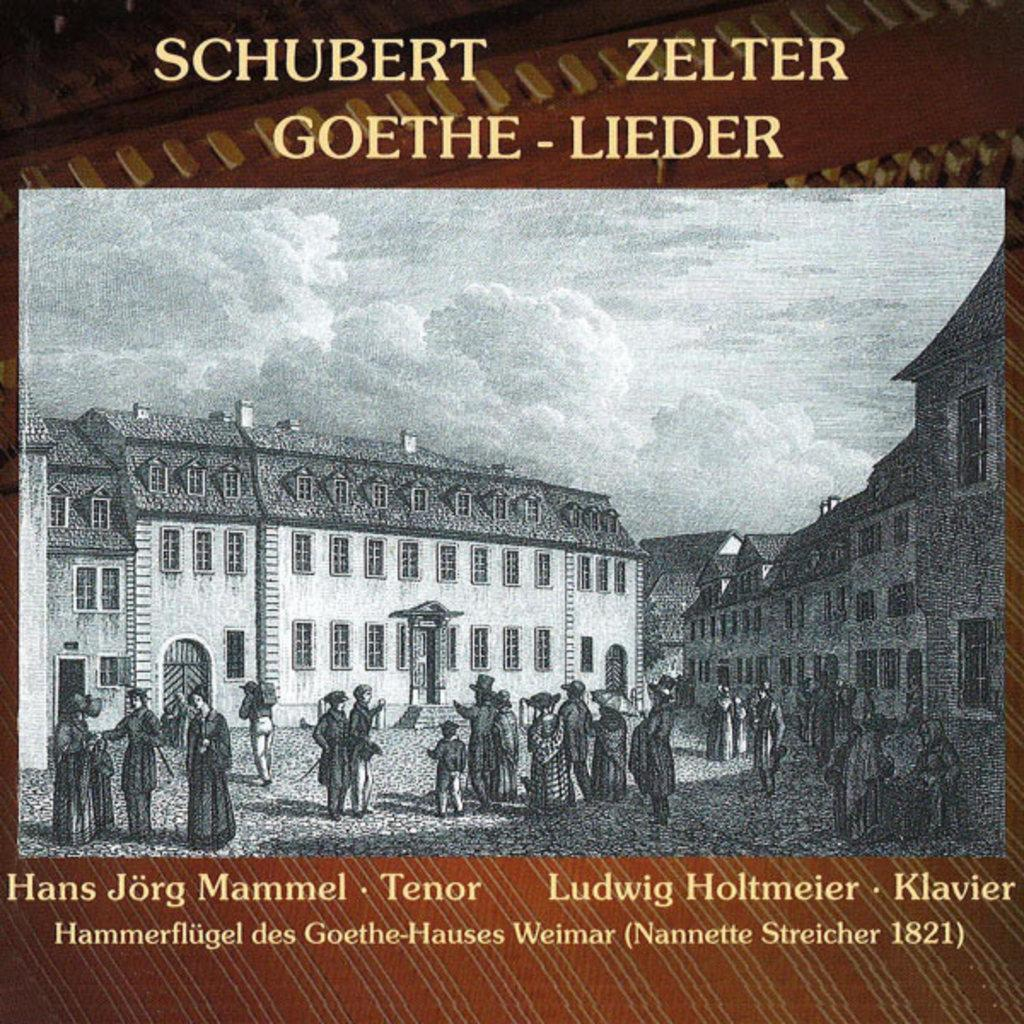What is featured in the image? There is a poster in the image. What can be seen on the poster? The poster contains people standing on the ground and depicts buildings. What part of the natural environment is visible on the poster? The sky is visible in the poster. What type of underwear is being worn by the people in the poster? There is no information about underwear in the image, as it only features a poster with people standing on the ground and buildings. 